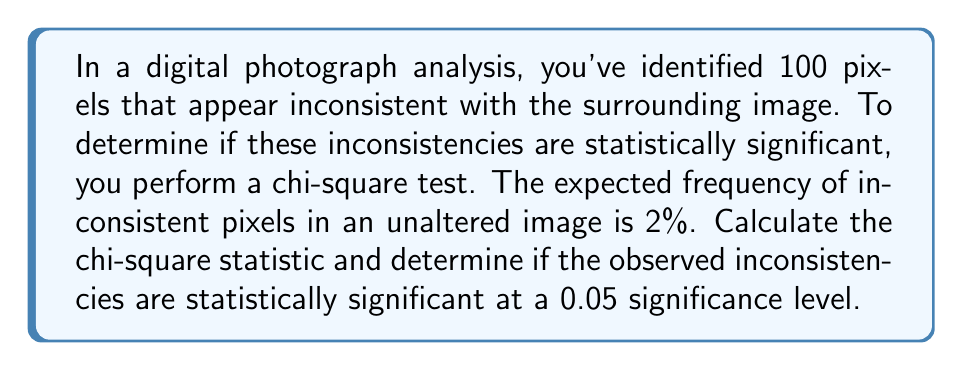Provide a solution to this math problem. To solve this problem, we'll follow these steps:

1) First, we need to calculate the expected number of inconsistent pixels:
   Expected = 100 * 0.02 = 2 pixels

2) We observe 100 inconsistent pixels.

3) The chi-square statistic is calculated using the formula:
   
   $$ \chi^2 = \sum \frac{(O - E)^2}{E} $$
   
   Where O is the observed frequency and E is the expected frequency.

4) Plugging in our values:
   
   $$ \chi^2 = \frac{(100 - 2)^2}{2} = \frac{98^2}{2} = \frac{9604}{2} = 4802 $$

5) To determine statistical significance, we compare this to the critical value from a chi-square distribution with 1 degree of freedom (df = 1) at α = 0.05.

6) The critical value for χ² with df = 1 at α = 0.05 is 3.841.

7) Since our calculated χ² (4802) is much larger than the critical value (3.841), we reject the null hypothesis.

Therefore, the observed pixel inconsistencies are statistically significant at the 0.05 level.
Answer: $\chi^2 = 4802$. The pixel inconsistencies are statistically significant (p < 0.05). 